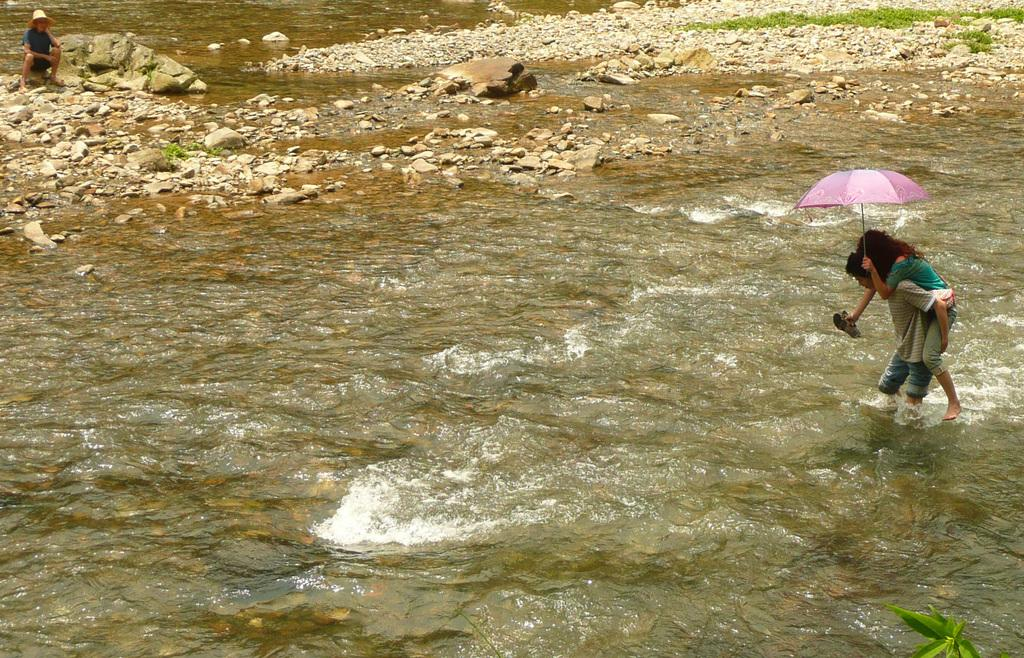How many people are in the image? There are people in the image, but the exact number is not specified. What is the woman holding in the image? The woman is holding an umbrella in the image. What is the natural environment like in the image? The image features water, leaves, rocks, and grass. What might be providing shelter from the water in the image? The woman holding an umbrella might be providing shelter from the water. What is the woman's opinion on the beetle crawling on the rock in the image? There is no beetle or mention of a rock in the image, so it is not possible to determine the woman's opinion on this matter. 